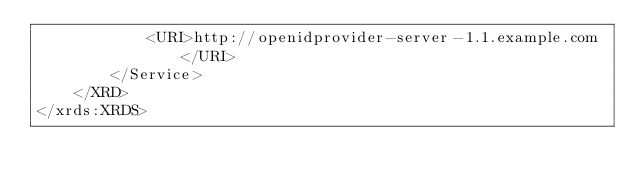Convert code to text. <code><loc_0><loc_0><loc_500><loc_500><_XML_>            <URI>http://openidprovider-server-1.1.example.com</URI>
        </Service>
    </XRD>
</xrds:XRDS>
</code> 